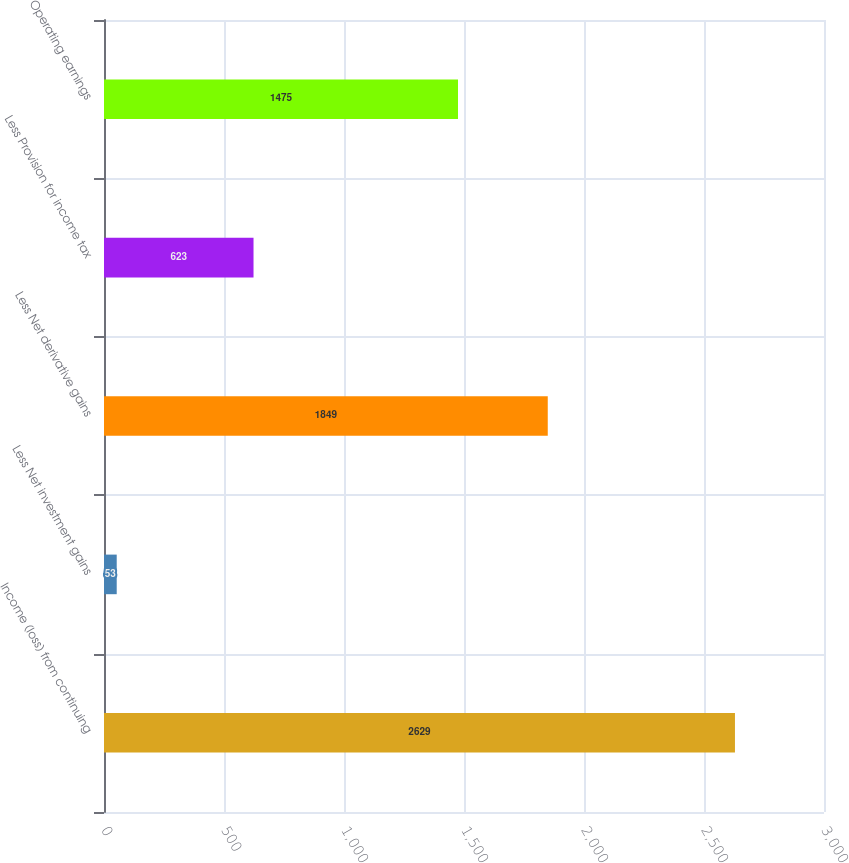<chart> <loc_0><loc_0><loc_500><loc_500><bar_chart><fcel>Income (loss) from continuing<fcel>Less Net investment gains<fcel>Less Net derivative gains<fcel>Less Provision for income tax<fcel>Operating earnings<nl><fcel>2629<fcel>53<fcel>1849<fcel>623<fcel>1475<nl></chart> 